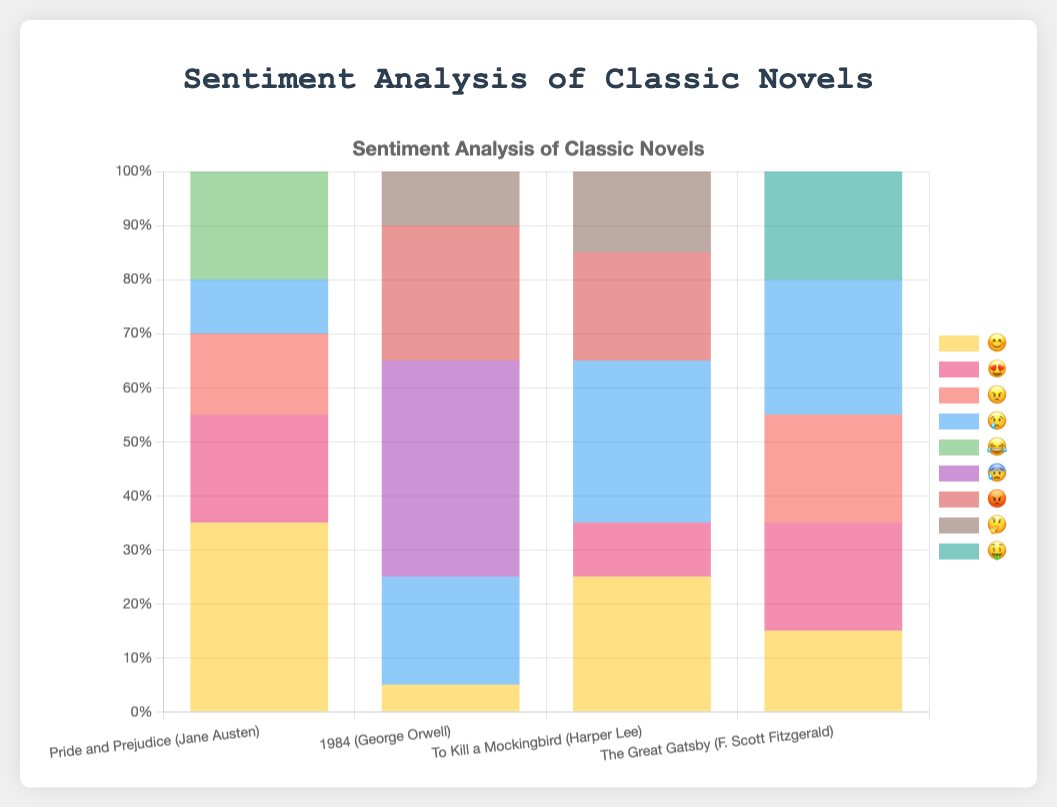Which novel shows the highest percentage of "😊" emotion? Identify the "😊" data across all novels and determine the highest percentage. "Pride and Prejudice" has 35%, which is the highest.
Answer: Pride and Prejudice How many novels have "😢" as the most prominent emotion? Count the number of novels where "😢" holds the highest percentage. "To Kill a Mockingbird" and "1984" both have "😢" as the top emotion.
Answer: 2 Which emotion is the least present in "1984"? From the sentiment analysis of "1984", the emotions listed and their respective percentages are: "😊" 5%, "😍" 0%, "😠" 0%, "😢" 20%, "😂" 0%, "😰" 40%, "😡" 25%, "🤔" 10%. The least present emotion is "😊" with 5%.
Answer: 😊 Compare the percentage of "😊" emotion in "Pride and Prejudice" and "To Kill a Mockingbird". Which one is higher? Check the "😊" percentages in both novels: "Pride and Prejudice" has 35% and "To Kill a Mockingbird" has 25%. "Pride and Prejudice" has the higher percentage.
Answer: Pride and Prejudice What is the summation of percentages for all emotions in "The Great Gatsby"? Sum the percentages of all the emotions for the novel: 25% + 20% + 20% + 20% + 15% = 100%.
Answer: 100% Which novel has the highest percentage of "😍" emotion and what is the value? Compare "😍" emotion percentages across novels: "Pride and Prejudice" has 20%, "1984" has 0%, "To Kill a Mockingbird" has 10%, "The Great Gatsby" has 20%. "Pride and Prejudice" and "The Great Gatsby" tie with 20%.
Answer: 20% What's the average percentage of "😢" across all novels? Sum the "😢" percentages for all novels and divide by the number of novels: (10% + 20% + 30% + 25%) / 4 = 21.25%.
Answer: 21.25% If you sum the percentages of "😡" and "😠" emotions for "To Kill a Mockingbird", what is the total? The percentages of "😡" and "😠" in "To Kill a Mockingbird" are 20% and 0%, respectively. Their sum is 20% + 0% = 20%.
Answer: 20% What emotion is predominantly associated with "1984" and what is its percentage? For "1984", the sentiment analysis shows "😰" as the highest emotion with 40%.
Answer: 😰 40% Which novel has the highest percentage of "😂" emotion and by how much does it surpass the second highest? "Pride and Prejudice" has 20% "😂" emotion, and it is the highest. The second highest is 0% in the other novels. Therefore, it surpasses them by 20%.
Answer: 20% 